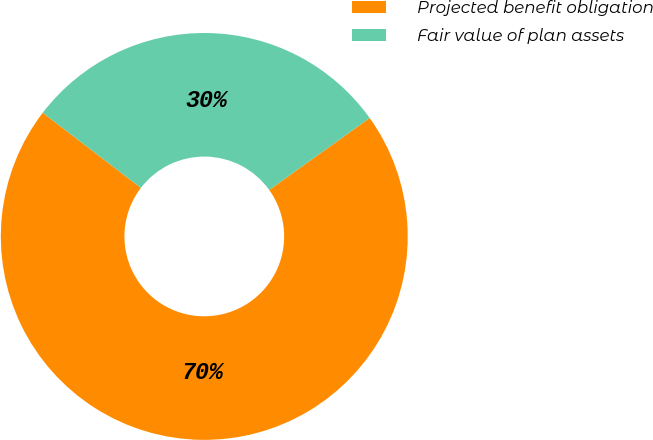Convert chart to OTSL. <chart><loc_0><loc_0><loc_500><loc_500><pie_chart><fcel>Projected benefit obligation<fcel>Fair value of plan assets<nl><fcel>70.29%<fcel>29.71%<nl></chart> 